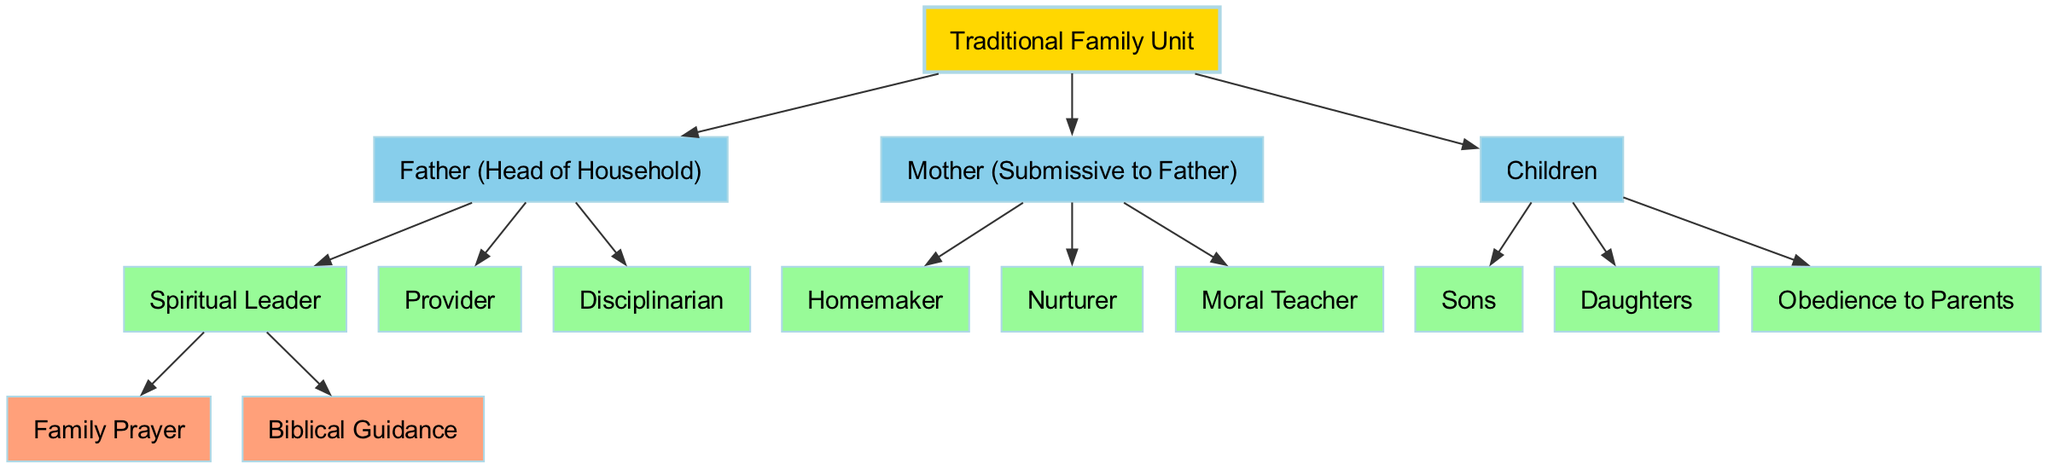What is the root node of the diagram? The root node is the main theme of the diagram, which is labeled as "Traditional Family Unit." It represents the overall structure and concept being illustrated.
Answer: Traditional Family Unit How many children does the Father node have? The Father node has three children: "Spiritual Leader," "Provider," and "Disciplinarian." By counting these nodes directly connected under the Father node, we find there are three.
Answer: 3 What role does the Mother play in the family structure? The Mother plays the role of "Submissive to Father," which is indicated directly under the Mother node. This is the primary description of her position within the diagram.
Answer: Submissive to Father Which node is a child of the Spiritual Leader? The Spiritual Leader has two children: "Family Prayer" and "Biblical Guidance." You can identify these by looking at the sub-structure under the Spiritual Leader node.
Answer: Family Prayer What do the Children nodes consist of? The Children node consists of "Sons," "Daughters," and "Obedience to Parents." When looking at the Children node, these three distinctions are listed as its direct children.
Answer: Sons, Daughters, Obedience to Parents What is the primary function of the Mother as represented in the diagram? The primary functions of the Mother are "Homemaker," "Nurturer," and "Moral Teacher." These roles are presented as sub-nodes originating from the Mother node.
Answer: Homemaker, Nurturer, Moral Teacher How many total roles or responsibilities are listed under the Father node? There are a total of three roles listed under the Father node: "Spiritual Leader," "Provider," and "Disciplinarian." By counting all the children under the Father, we obtain the total number of roles.
Answer: 3 Which node expresses the importance of spiritual guidance in the family? The node that expresses spiritual guidance is "Spiritual Leader," as it highlights the values of "Family Prayer" and "Biblical Guidance" as its children. This node is responsible for conveying the spiritual aspect of guidance in the family.
Answer: Spiritual Leader How many total distinct roles are described in the diagram? The total distinct roles can be calculated by combining all the children roles from each parent node: 3 (Father) + 3 (Mother) + 3 (Children) = 9 distinct roles.
Answer: 9 